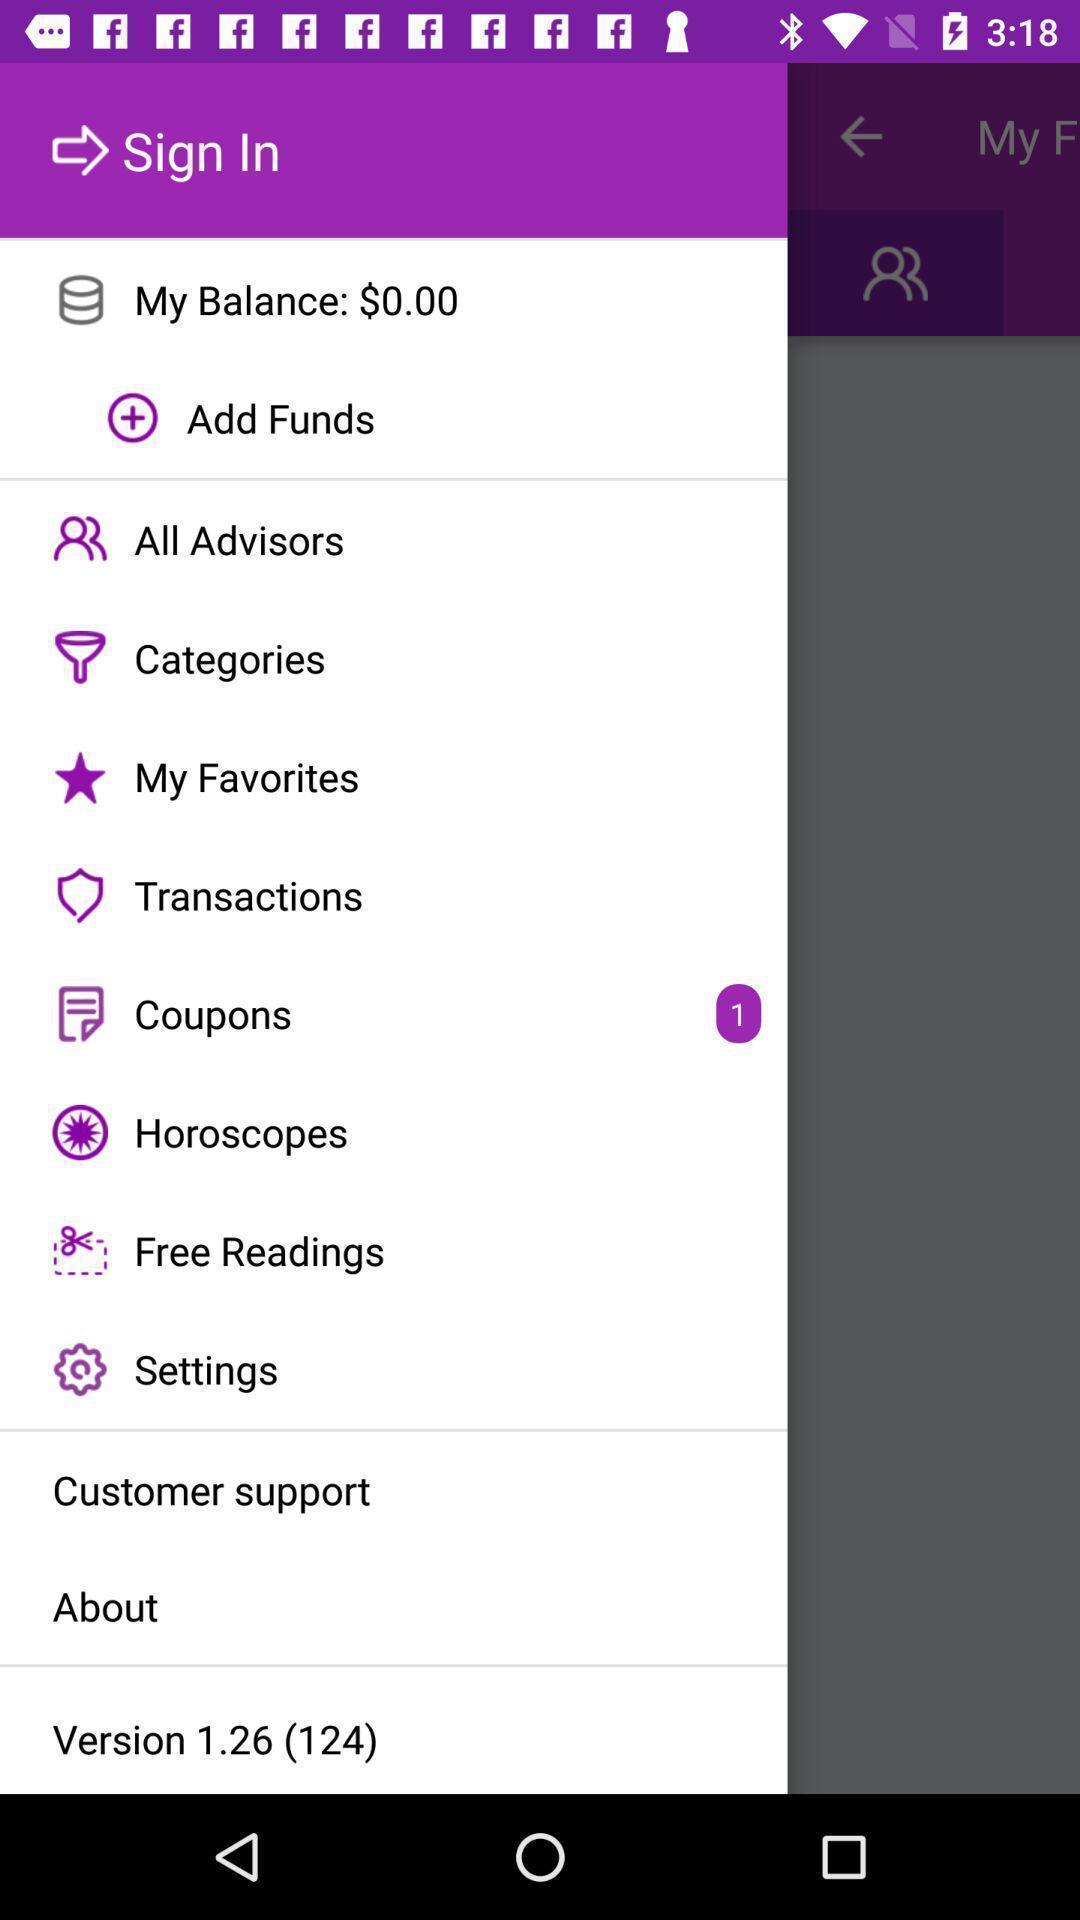Provide a textual representation of this image. Sign in page of a payment app. 